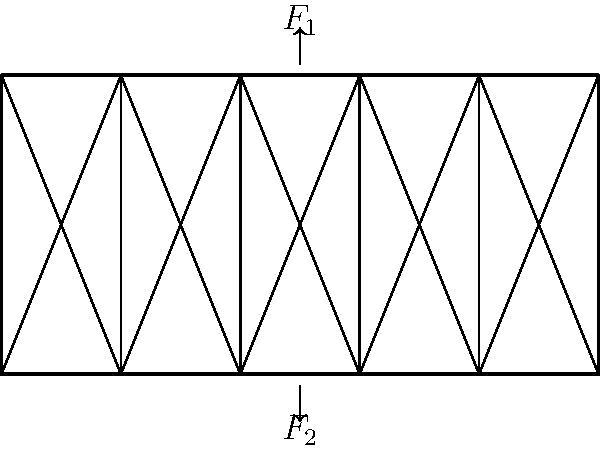In honor of Sidney Poitier's iconic role as Homer Smith in "Lilies of the Field," where he builds a chapel, let's consider a bridge structure. The truss bridge shown above is subjected to two equal and opposite forces $F_1$ and $F_2$ at its midpoint. If the magnitude of each force is 100 kN, what is the maximum normal stress in the vertical members of the truss, assuming each vertical member has a cross-sectional area of 0.002 m²? To solve this problem, let's follow these steps:

1) First, we need to understand that the two forces $F_1$ and $F_2$ create a couple (moment) at the center of the bridge.

2) This couple will be distributed equally to the two nearest vertical members on either side of the center.

3) The distance between these vertical members is 20 units (as seen in the diagram).

4) The moment created by the forces is:
   $M = F_1 \times d = 100 \text{ kN} \times 20 \text{ m} = 2000 \text{ kN}\cdot\text{m}$

5) This moment is resisted by the two vertical members, each taking half of the load:
   $F_{vertical} = \frac{M/2}{d} = \frac{1000 \text{ kN}\cdot\text{m}}{20 \text{ m}} = 50 \text{ kN}$

6) The normal stress in each vertical member is:
   $\sigma = \frac{F}{A} = \frac{50 \text{ kN}}{0.002 \text{ m}^2} = 25,000 \text{ kN}/\text{m}^2 = 25 \text{ MPa}$

Therefore, the maximum normal stress in the vertical members is 25 MPa.
Answer: 25 MPa 